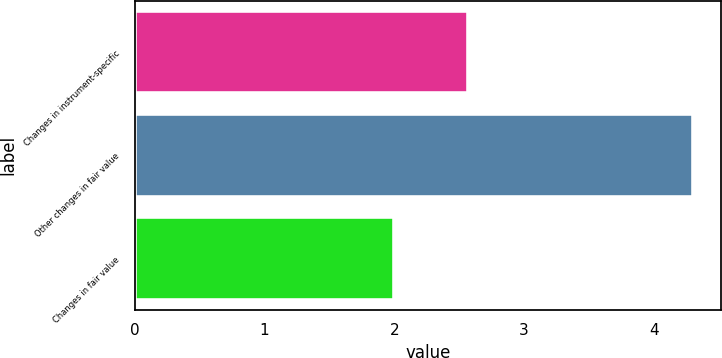Convert chart. <chart><loc_0><loc_0><loc_500><loc_500><bar_chart><fcel>Changes in instrument-specific<fcel>Other changes in fair value<fcel>Changes in fair value<nl><fcel>2.57<fcel>4.3<fcel>2<nl></chart> 